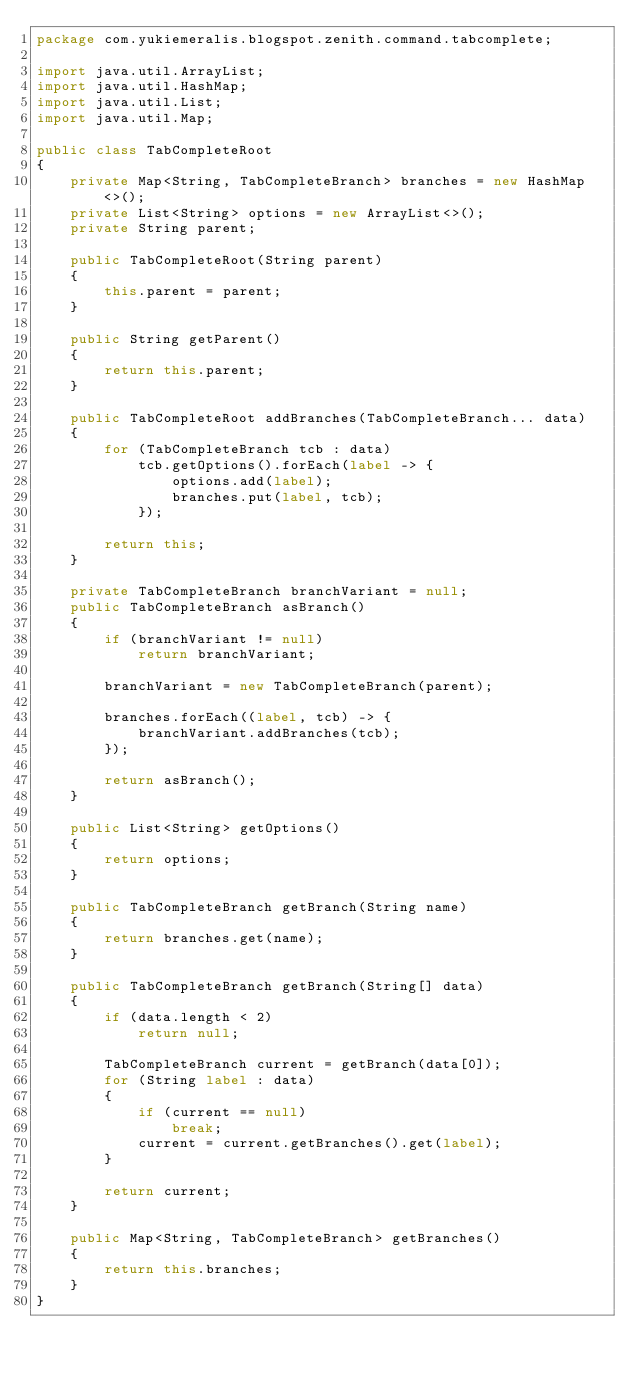Convert code to text. <code><loc_0><loc_0><loc_500><loc_500><_Java_>package com.yukiemeralis.blogspot.zenith.command.tabcomplete;

import java.util.ArrayList;
import java.util.HashMap;
import java.util.List;
import java.util.Map;

public class TabCompleteRoot
{
    private Map<String, TabCompleteBranch> branches = new HashMap<>();
    private List<String> options = new ArrayList<>();
    private String parent;

    public TabCompleteRoot(String parent)
    {
        this.parent = parent;
    }

    public String getParent()
    {
        return this.parent;
    }

    public TabCompleteRoot addBranches(TabCompleteBranch... data)
    {
        for (TabCompleteBranch tcb : data)
            tcb.getOptions().forEach(label -> {
                options.add(label);
                branches.put(label, tcb);
            });

        return this;
    }

    private TabCompleteBranch branchVariant = null;
    public TabCompleteBranch asBranch()
    {
        if (branchVariant != null)
            return branchVariant;

        branchVariant = new TabCompleteBranch(parent);

        branches.forEach((label, tcb) -> {
            branchVariant.addBranches(tcb);
        });

        return asBranch();
    }

    public List<String> getOptions()
    {
        return options;
    }

    public TabCompleteBranch getBranch(String name)
    {
        return branches.get(name);
    }

    public TabCompleteBranch getBranch(String[] data)
    {
        if (data.length < 2)
            return null;

        TabCompleteBranch current = getBranch(data[0]);
        for (String label : data)
        {
            if (current == null)
                break;
            current = current.getBranches().get(label);
        }

        return current;
    }

    public Map<String, TabCompleteBranch> getBranches()
    {
        return this.branches;
    }
}
</code> 